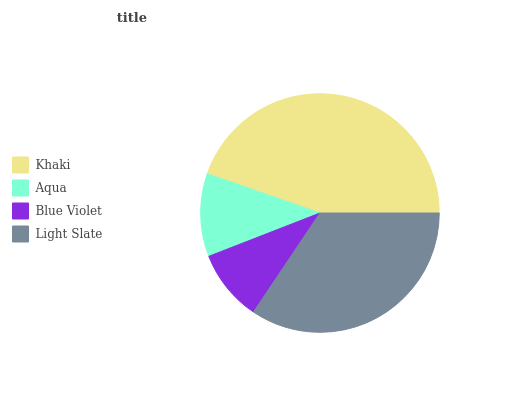Is Blue Violet the minimum?
Answer yes or no. Yes. Is Khaki the maximum?
Answer yes or no. Yes. Is Aqua the minimum?
Answer yes or no. No. Is Aqua the maximum?
Answer yes or no. No. Is Khaki greater than Aqua?
Answer yes or no. Yes. Is Aqua less than Khaki?
Answer yes or no. Yes. Is Aqua greater than Khaki?
Answer yes or no. No. Is Khaki less than Aqua?
Answer yes or no. No. Is Light Slate the high median?
Answer yes or no. Yes. Is Aqua the low median?
Answer yes or no. Yes. Is Khaki the high median?
Answer yes or no. No. Is Light Slate the low median?
Answer yes or no. No. 